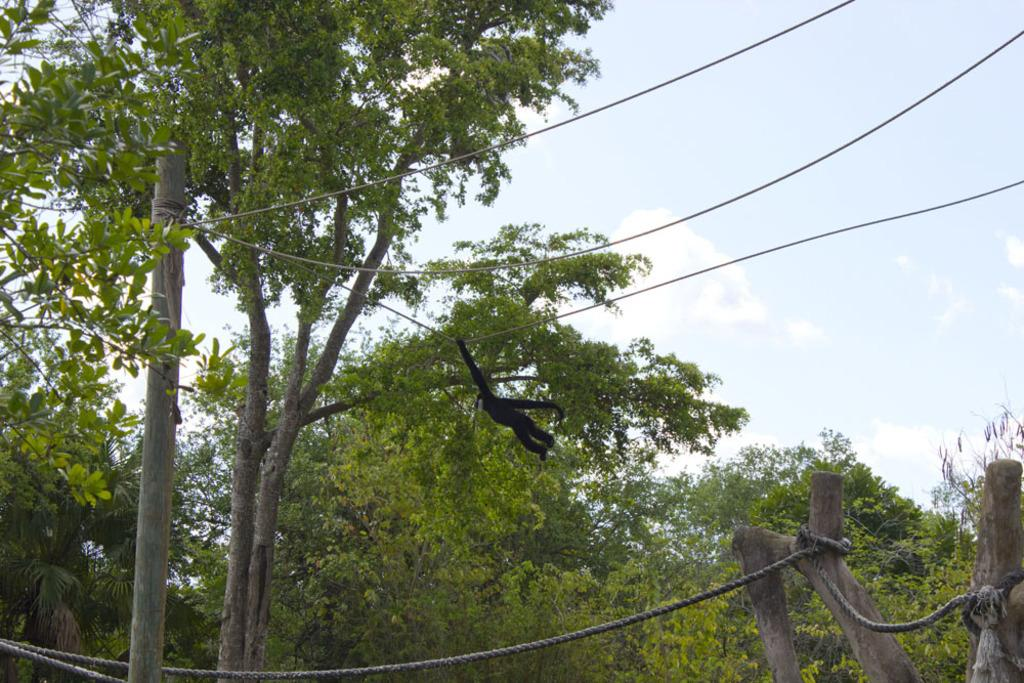What type of vegetation can be seen in the image? There are trees in the image. What is attached to one of the trees in the image? A rope is tied to a tree in the image. What animal is hanging on the rope in the image? A black color monkey is hanging on the rope in the image. What is visible at the top of the image? The sky is visible at the top of the image. Where is the office located in the image? There is no office present in the image. What type of food is being served in the lunchroom in the image? There is no lunchroom present in the image. 